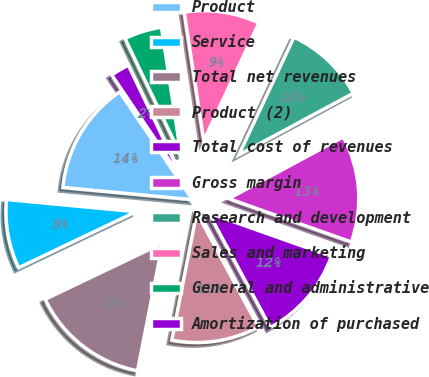<chart> <loc_0><loc_0><loc_500><loc_500><pie_chart><fcel>Product<fcel>Service<fcel>Total net revenues<fcel>Product (2)<fcel>Total cost of revenues<fcel>Gross margin<fcel>Research and development<fcel>Sales and marketing<fcel>General and administrative<fcel>Amortization of purchased<nl><fcel>14.06%<fcel>8.59%<fcel>14.84%<fcel>10.94%<fcel>11.72%<fcel>13.28%<fcel>10.16%<fcel>9.38%<fcel>4.69%<fcel>2.35%<nl></chart> 